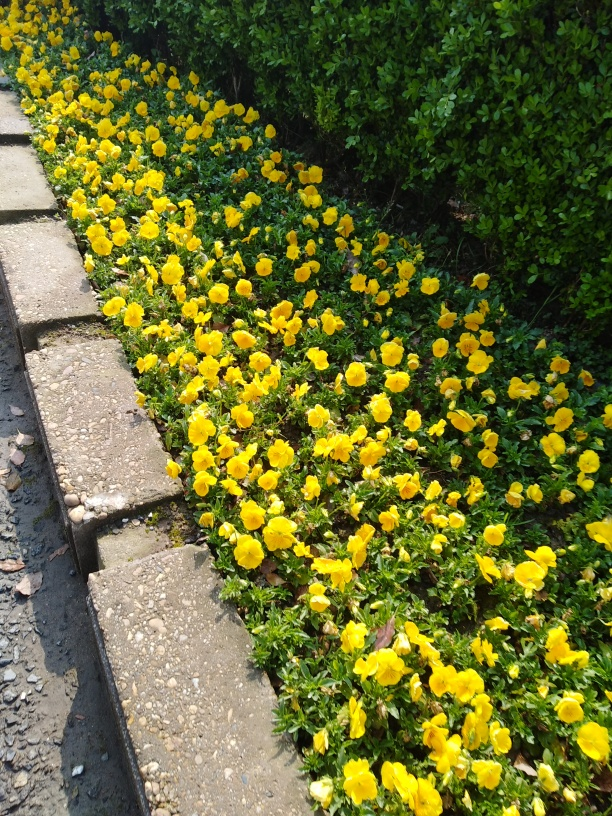What is the significance of these flowers? Pansies are often associated with love and admiration. They are also used in various cultural and artistic contexts, known for their symbolism and beauty. Do they have uses beyond ornamental? Besides their ornamental value, pansies are edible and can be used to add a splash of color to salads and desserts. They also have traditional medicinal uses. 